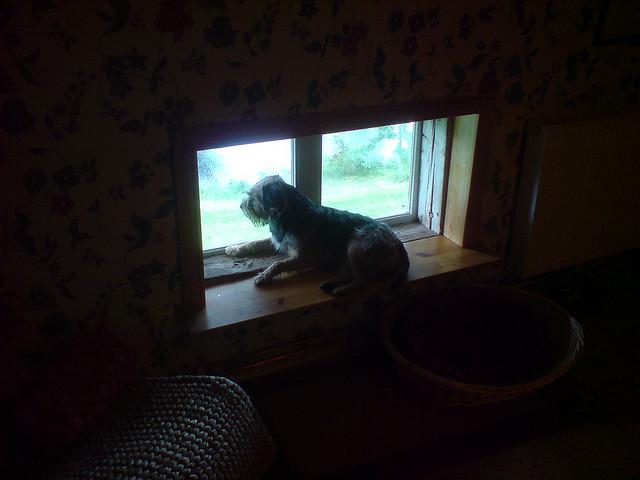What time of day is it?
Give a very brief answer. Daytime. What color are the cat's eyes?
Answer briefly. No cat. What is looking out the window?
Quick response, please. Dog. Is it brighter inside or outdoors?
Concise answer only. Outdoors. 